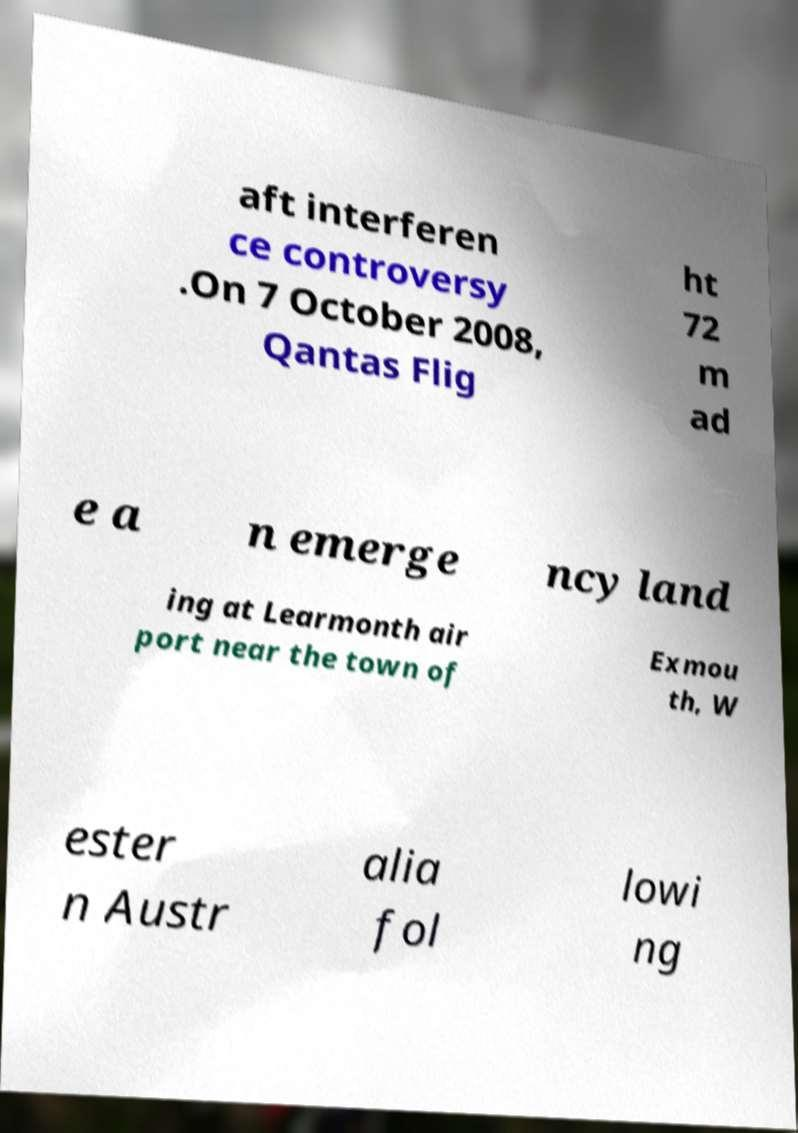Could you extract and type out the text from this image? aft interferen ce controversy .On 7 October 2008, Qantas Flig ht 72 m ad e a n emerge ncy land ing at Learmonth air port near the town of Exmou th, W ester n Austr alia fol lowi ng 